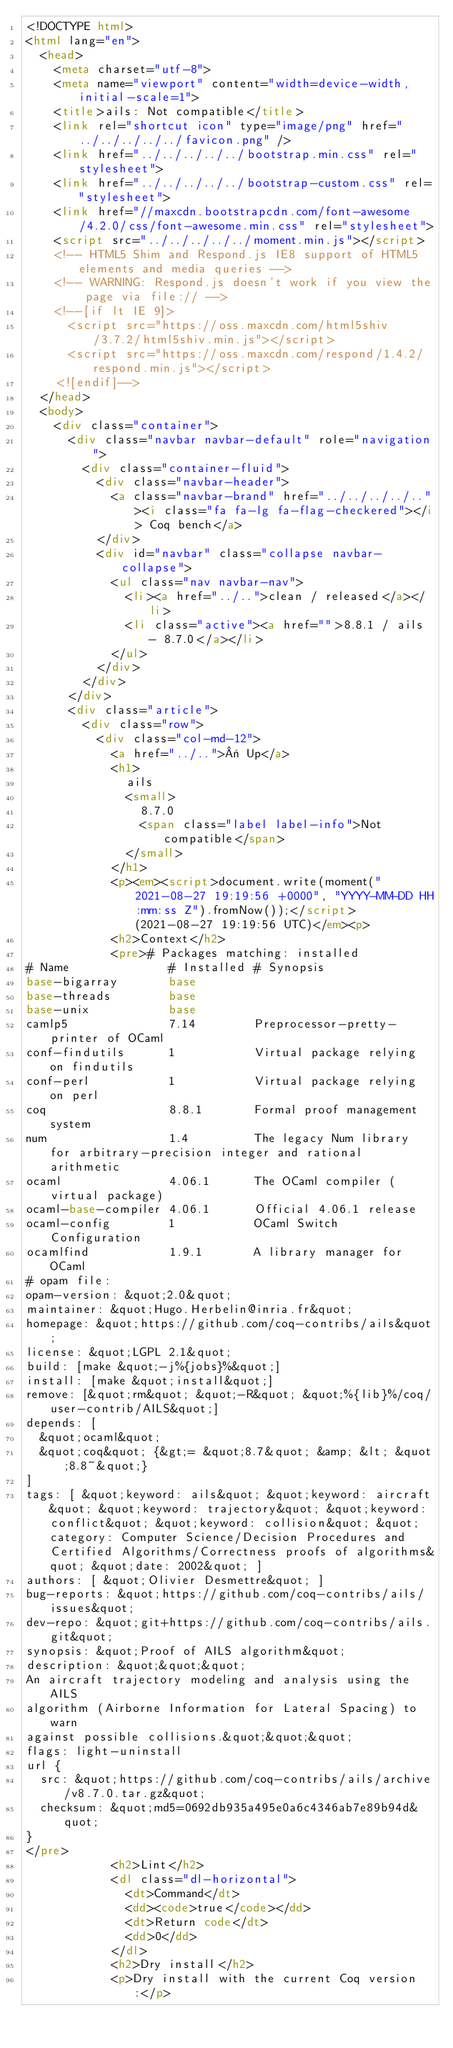Convert code to text. <code><loc_0><loc_0><loc_500><loc_500><_HTML_><!DOCTYPE html>
<html lang="en">
  <head>
    <meta charset="utf-8">
    <meta name="viewport" content="width=device-width, initial-scale=1">
    <title>ails: Not compatible</title>
    <link rel="shortcut icon" type="image/png" href="../../../../../favicon.png" />
    <link href="../../../../../bootstrap.min.css" rel="stylesheet">
    <link href="../../../../../bootstrap-custom.css" rel="stylesheet">
    <link href="//maxcdn.bootstrapcdn.com/font-awesome/4.2.0/css/font-awesome.min.css" rel="stylesheet">
    <script src="../../../../../moment.min.js"></script>
    <!-- HTML5 Shim and Respond.js IE8 support of HTML5 elements and media queries -->
    <!-- WARNING: Respond.js doesn't work if you view the page via file:// -->
    <!--[if lt IE 9]>
      <script src="https://oss.maxcdn.com/html5shiv/3.7.2/html5shiv.min.js"></script>
      <script src="https://oss.maxcdn.com/respond/1.4.2/respond.min.js"></script>
    <![endif]-->
  </head>
  <body>
    <div class="container">
      <div class="navbar navbar-default" role="navigation">
        <div class="container-fluid">
          <div class="navbar-header">
            <a class="navbar-brand" href="../../../../.."><i class="fa fa-lg fa-flag-checkered"></i> Coq bench</a>
          </div>
          <div id="navbar" class="collapse navbar-collapse">
            <ul class="nav navbar-nav">
              <li><a href="../..">clean / released</a></li>
              <li class="active"><a href="">8.8.1 / ails - 8.7.0</a></li>
            </ul>
          </div>
        </div>
      </div>
      <div class="article">
        <div class="row">
          <div class="col-md-12">
            <a href="../..">« Up</a>
            <h1>
              ails
              <small>
                8.7.0
                <span class="label label-info">Not compatible</span>
              </small>
            </h1>
            <p><em><script>document.write(moment("2021-08-27 19:19:56 +0000", "YYYY-MM-DD HH:mm:ss Z").fromNow());</script> (2021-08-27 19:19:56 UTC)</em><p>
            <h2>Context</h2>
            <pre># Packages matching: installed
# Name              # Installed # Synopsis
base-bigarray       base
base-threads        base
base-unix           base
camlp5              7.14        Preprocessor-pretty-printer of OCaml
conf-findutils      1           Virtual package relying on findutils
conf-perl           1           Virtual package relying on perl
coq                 8.8.1       Formal proof management system
num                 1.4         The legacy Num library for arbitrary-precision integer and rational arithmetic
ocaml               4.06.1      The OCaml compiler (virtual package)
ocaml-base-compiler 4.06.1      Official 4.06.1 release
ocaml-config        1           OCaml Switch Configuration
ocamlfind           1.9.1       A library manager for OCaml
# opam file:
opam-version: &quot;2.0&quot;
maintainer: &quot;Hugo.Herbelin@inria.fr&quot;
homepage: &quot;https://github.com/coq-contribs/ails&quot;
license: &quot;LGPL 2.1&quot;
build: [make &quot;-j%{jobs}%&quot;]
install: [make &quot;install&quot;]
remove: [&quot;rm&quot; &quot;-R&quot; &quot;%{lib}%/coq/user-contrib/AILS&quot;]
depends: [
  &quot;ocaml&quot;
  &quot;coq&quot; {&gt;= &quot;8.7&quot; &amp; &lt; &quot;8.8~&quot;}
]
tags: [ &quot;keyword: ails&quot; &quot;keyword: aircraft&quot; &quot;keyword: trajectory&quot; &quot;keyword: conflict&quot; &quot;keyword: collision&quot; &quot;category: Computer Science/Decision Procedures and Certified Algorithms/Correctness proofs of algorithms&quot; &quot;date: 2002&quot; ]
authors: [ &quot;Olivier Desmettre&quot; ]
bug-reports: &quot;https://github.com/coq-contribs/ails/issues&quot;
dev-repo: &quot;git+https://github.com/coq-contribs/ails.git&quot;
synopsis: &quot;Proof of AILS algorithm&quot;
description: &quot;&quot;&quot;
An aircraft trajectory modeling and analysis using the AILS
algorithm (Airborne Information for Lateral Spacing) to warn
against possible collisions.&quot;&quot;&quot;
flags: light-uninstall
url {
  src: &quot;https://github.com/coq-contribs/ails/archive/v8.7.0.tar.gz&quot;
  checksum: &quot;md5=0692db935a495e0a6c4346ab7e89b94d&quot;
}
</pre>
            <h2>Lint</h2>
            <dl class="dl-horizontal">
              <dt>Command</dt>
              <dd><code>true</code></dd>
              <dt>Return code</dt>
              <dd>0</dd>
            </dl>
            <h2>Dry install</h2>
            <p>Dry install with the current Coq version:</p></code> 